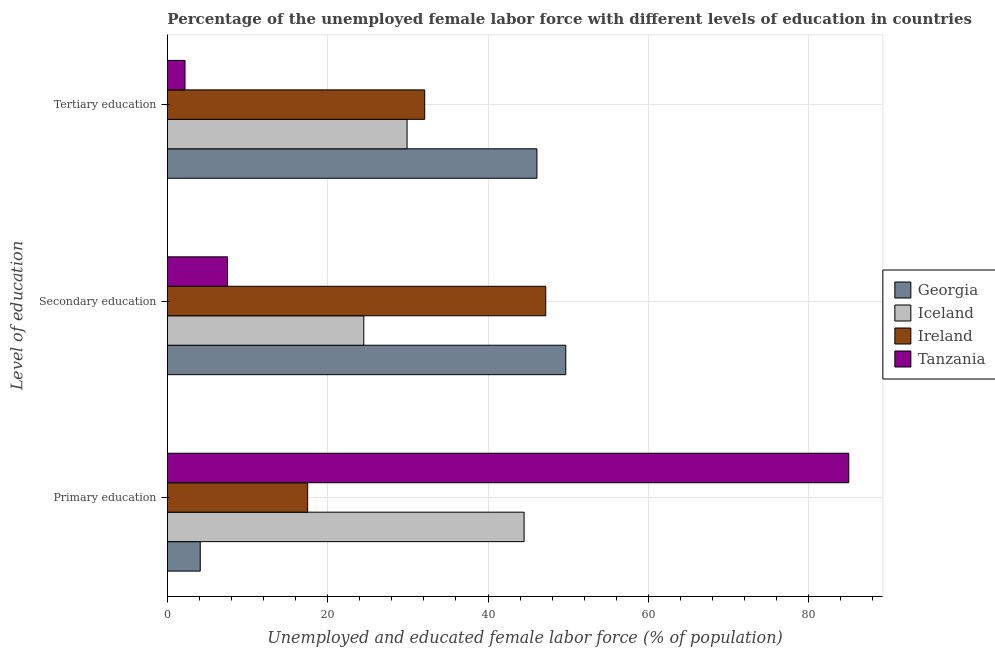Are the number of bars on each tick of the Y-axis equal?
Your response must be concise. Yes. How many bars are there on the 3rd tick from the top?
Offer a terse response. 4. How many bars are there on the 3rd tick from the bottom?
Provide a succinct answer. 4. What is the label of the 3rd group of bars from the top?
Your answer should be compact. Primary education. What is the percentage of female labor force who received secondary education in Georgia?
Ensure brevity in your answer.  49.7. Across all countries, what is the maximum percentage of female labor force who received primary education?
Keep it short and to the point. 85. Across all countries, what is the minimum percentage of female labor force who received primary education?
Keep it short and to the point. 4.1. In which country was the percentage of female labor force who received tertiary education maximum?
Your response must be concise. Georgia. In which country was the percentage of female labor force who received primary education minimum?
Ensure brevity in your answer.  Georgia. What is the total percentage of female labor force who received tertiary education in the graph?
Make the answer very short. 110.3. What is the difference between the percentage of female labor force who received primary education in Ireland and that in Tanzania?
Your response must be concise. -67.5. What is the difference between the percentage of female labor force who received tertiary education in Georgia and the percentage of female labor force who received secondary education in Iceland?
Your response must be concise. 21.6. What is the average percentage of female labor force who received tertiary education per country?
Offer a terse response. 27.57. What is the difference between the percentage of female labor force who received tertiary education and percentage of female labor force who received primary education in Georgia?
Ensure brevity in your answer.  42. In how many countries, is the percentage of female labor force who received tertiary education greater than 76 %?
Offer a terse response. 0. What is the ratio of the percentage of female labor force who received primary education in Ireland to that in Tanzania?
Make the answer very short. 0.21. Is the percentage of female labor force who received tertiary education in Iceland less than that in Ireland?
Your response must be concise. Yes. Is the difference between the percentage of female labor force who received secondary education in Iceland and Tanzania greater than the difference between the percentage of female labor force who received tertiary education in Iceland and Tanzania?
Keep it short and to the point. No. What is the difference between the highest and the second highest percentage of female labor force who received primary education?
Your response must be concise. 40.5. What is the difference between the highest and the lowest percentage of female labor force who received tertiary education?
Your answer should be very brief. 43.9. In how many countries, is the percentage of female labor force who received secondary education greater than the average percentage of female labor force who received secondary education taken over all countries?
Your answer should be compact. 2. Is it the case that in every country, the sum of the percentage of female labor force who received primary education and percentage of female labor force who received secondary education is greater than the percentage of female labor force who received tertiary education?
Offer a very short reply. Yes. How many bars are there?
Make the answer very short. 12. Are all the bars in the graph horizontal?
Your answer should be very brief. Yes. Are the values on the major ticks of X-axis written in scientific E-notation?
Provide a succinct answer. No. Does the graph contain grids?
Make the answer very short. Yes. How many legend labels are there?
Offer a very short reply. 4. How are the legend labels stacked?
Your answer should be very brief. Vertical. What is the title of the graph?
Provide a succinct answer. Percentage of the unemployed female labor force with different levels of education in countries. Does "Micronesia" appear as one of the legend labels in the graph?
Your response must be concise. No. What is the label or title of the X-axis?
Keep it short and to the point. Unemployed and educated female labor force (% of population). What is the label or title of the Y-axis?
Ensure brevity in your answer.  Level of education. What is the Unemployed and educated female labor force (% of population) in Georgia in Primary education?
Your answer should be very brief. 4.1. What is the Unemployed and educated female labor force (% of population) of Iceland in Primary education?
Offer a terse response. 44.5. What is the Unemployed and educated female labor force (% of population) of Ireland in Primary education?
Your answer should be very brief. 17.5. What is the Unemployed and educated female labor force (% of population) of Tanzania in Primary education?
Your response must be concise. 85. What is the Unemployed and educated female labor force (% of population) of Georgia in Secondary education?
Make the answer very short. 49.7. What is the Unemployed and educated female labor force (% of population) in Iceland in Secondary education?
Give a very brief answer. 24.5. What is the Unemployed and educated female labor force (% of population) of Ireland in Secondary education?
Your answer should be very brief. 47.2. What is the Unemployed and educated female labor force (% of population) in Georgia in Tertiary education?
Your answer should be compact. 46.1. What is the Unemployed and educated female labor force (% of population) of Iceland in Tertiary education?
Your answer should be compact. 29.9. What is the Unemployed and educated female labor force (% of population) of Ireland in Tertiary education?
Provide a short and direct response. 32.1. What is the Unemployed and educated female labor force (% of population) in Tanzania in Tertiary education?
Provide a succinct answer. 2.2. Across all Level of education, what is the maximum Unemployed and educated female labor force (% of population) in Georgia?
Make the answer very short. 49.7. Across all Level of education, what is the maximum Unemployed and educated female labor force (% of population) of Iceland?
Provide a succinct answer. 44.5. Across all Level of education, what is the maximum Unemployed and educated female labor force (% of population) in Ireland?
Provide a short and direct response. 47.2. Across all Level of education, what is the minimum Unemployed and educated female labor force (% of population) of Georgia?
Your response must be concise. 4.1. Across all Level of education, what is the minimum Unemployed and educated female labor force (% of population) in Iceland?
Make the answer very short. 24.5. Across all Level of education, what is the minimum Unemployed and educated female labor force (% of population) in Tanzania?
Provide a succinct answer. 2.2. What is the total Unemployed and educated female labor force (% of population) of Georgia in the graph?
Provide a short and direct response. 99.9. What is the total Unemployed and educated female labor force (% of population) of Iceland in the graph?
Make the answer very short. 98.9. What is the total Unemployed and educated female labor force (% of population) in Ireland in the graph?
Your answer should be very brief. 96.8. What is the total Unemployed and educated female labor force (% of population) of Tanzania in the graph?
Your answer should be compact. 94.7. What is the difference between the Unemployed and educated female labor force (% of population) of Georgia in Primary education and that in Secondary education?
Ensure brevity in your answer.  -45.6. What is the difference between the Unemployed and educated female labor force (% of population) of Ireland in Primary education and that in Secondary education?
Provide a short and direct response. -29.7. What is the difference between the Unemployed and educated female labor force (% of population) of Tanzania in Primary education and that in Secondary education?
Give a very brief answer. 77.5. What is the difference between the Unemployed and educated female labor force (% of population) of Georgia in Primary education and that in Tertiary education?
Make the answer very short. -42. What is the difference between the Unemployed and educated female labor force (% of population) in Iceland in Primary education and that in Tertiary education?
Offer a terse response. 14.6. What is the difference between the Unemployed and educated female labor force (% of population) of Ireland in Primary education and that in Tertiary education?
Make the answer very short. -14.6. What is the difference between the Unemployed and educated female labor force (% of population) in Tanzania in Primary education and that in Tertiary education?
Provide a succinct answer. 82.8. What is the difference between the Unemployed and educated female labor force (% of population) of Georgia in Secondary education and that in Tertiary education?
Ensure brevity in your answer.  3.6. What is the difference between the Unemployed and educated female labor force (% of population) of Georgia in Primary education and the Unemployed and educated female labor force (% of population) of Iceland in Secondary education?
Give a very brief answer. -20.4. What is the difference between the Unemployed and educated female labor force (% of population) in Georgia in Primary education and the Unemployed and educated female labor force (% of population) in Ireland in Secondary education?
Provide a short and direct response. -43.1. What is the difference between the Unemployed and educated female labor force (% of population) in Georgia in Primary education and the Unemployed and educated female labor force (% of population) in Tanzania in Secondary education?
Give a very brief answer. -3.4. What is the difference between the Unemployed and educated female labor force (% of population) in Iceland in Primary education and the Unemployed and educated female labor force (% of population) in Tanzania in Secondary education?
Your answer should be very brief. 37. What is the difference between the Unemployed and educated female labor force (% of population) in Ireland in Primary education and the Unemployed and educated female labor force (% of population) in Tanzania in Secondary education?
Provide a short and direct response. 10. What is the difference between the Unemployed and educated female labor force (% of population) of Georgia in Primary education and the Unemployed and educated female labor force (% of population) of Iceland in Tertiary education?
Make the answer very short. -25.8. What is the difference between the Unemployed and educated female labor force (% of population) of Georgia in Primary education and the Unemployed and educated female labor force (% of population) of Ireland in Tertiary education?
Your response must be concise. -28. What is the difference between the Unemployed and educated female labor force (% of population) in Georgia in Primary education and the Unemployed and educated female labor force (% of population) in Tanzania in Tertiary education?
Your answer should be compact. 1.9. What is the difference between the Unemployed and educated female labor force (% of population) of Iceland in Primary education and the Unemployed and educated female labor force (% of population) of Ireland in Tertiary education?
Your answer should be very brief. 12.4. What is the difference between the Unemployed and educated female labor force (% of population) in Iceland in Primary education and the Unemployed and educated female labor force (% of population) in Tanzania in Tertiary education?
Provide a short and direct response. 42.3. What is the difference between the Unemployed and educated female labor force (% of population) of Georgia in Secondary education and the Unemployed and educated female labor force (% of population) of Iceland in Tertiary education?
Provide a succinct answer. 19.8. What is the difference between the Unemployed and educated female labor force (% of population) in Georgia in Secondary education and the Unemployed and educated female labor force (% of population) in Ireland in Tertiary education?
Ensure brevity in your answer.  17.6. What is the difference between the Unemployed and educated female labor force (% of population) of Georgia in Secondary education and the Unemployed and educated female labor force (% of population) of Tanzania in Tertiary education?
Make the answer very short. 47.5. What is the difference between the Unemployed and educated female labor force (% of population) in Iceland in Secondary education and the Unemployed and educated female labor force (% of population) in Ireland in Tertiary education?
Provide a succinct answer. -7.6. What is the difference between the Unemployed and educated female labor force (% of population) in Iceland in Secondary education and the Unemployed and educated female labor force (% of population) in Tanzania in Tertiary education?
Your answer should be compact. 22.3. What is the average Unemployed and educated female labor force (% of population) of Georgia per Level of education?
Provide a short and direct response. 33.3. What is the average Unemployed and educated female labor force (% of population) in Iceland per Level of education?
Your response must be concise. 32.97. What is the average Unemployed and educated female labor force (% of population) of Ireland per Level of education?
Your answer should be compact. 32.27. What is the average Unemployed and educated female labor force (% of population) of Tanzania per Level of education?
Provide a short and direct response. 31.57. What is the difference between the Unemployed and educated female labor force (% of population) in Georgia and Unemployed and educated female labor force (% of population) in Iceland in Primary education?
Offer a very short reply. -40.4. What is the difference between the Unemployed and educated female labor force (% of population) in Georgia and Unemployed and educated female labor force (% of population) in Ireland in Primary education?
Give a very brief answer. -13.4. What is the difference between the Unemployed and educated female labor force (% of population) in Georgia and Unemployed and educated female labor force (% of population) in Tanzania in Primary education?
Make the answer very short. -80.9. What is the difference between the Unemployed and educated female labor force (% of population) of Iceland and Unemployed and educated female labor force (% of population) of Tanzania in Primary education?
Offer a terse response. -40.5. What is the difference between the Unemployed and educated female labor force (% of population) in Ireland and Unemployed and educated female labor force (% of population) in Tanzania in Primary education?
Offer a very short reply. -67.5. What is the difference between the Unemployed and educated female labor force (% of population) of Georgia and Unemployed and educated female labor force (% of population) of Iceland in Secondary education?
Your answer should be compact. 25.2. What is the difference between the Unemployed and educated female labor force (% of population) of Georgia and Unemployed and educated female labor force (% of population) of Tanzania in Secondary education?
Ensure brevity in your answer.  42.2. What is the difference between the Unemployed and educated female labor force (% of population) in Iceland and Unemployed and educated female labor force (% of population) in Ireland in Secondary education?
Provide a short and direct response. -22.7. What is the difference between the Unemployed and educated female labor force (% of population) in Iceland and Unemployed and educated female labor force (% of population) in Tanzania in Secondary education?
Keep it short and to the point. 17. What is the difference between the Unemployed and educated female labor force (% of population) of Ireland and Unemployed and educated female labor force (% of population) of Tanzania in Secondary education?
Make the answer very short. 39.7. What is the difference between the Unemployed and educated female labor force (% of population) of Georgia and Unemployed and educated female labor force (% of population) of Iceland in Tertiary education?
Give a very brief answer. 16.2. What is the difference between the Unemployed and educated female labor force (% of population) in Georgia and Unemployed and educated female labor force (% of population) in Tanzania in Tertiary education?
Provide a succinct answer. 43.9. What is the difference between the Unemployed and educated female labor force (% of population) of Iceland and Unemployed and educated female labor force (% of population) of Ireland in Tertiary education?
Keep it short and to the point. -2.2. What is the difference between the Unemployed and educated female labor force (% of population) of Iceland and Unemployed and educated female labor force (% of population) of Tanzania in Tertiary education?
Provide a succinct answer. 27.7. What is the difference between the Unemployed and educated female labor force (% of population) in Ireland and Unemployed and educated female labor force (% of population) in Tanzania in Tertiary education?
Provide a short and direct response. 29.9. What is the ratio of the Unemployed and educated female labor force (% of population) in Georgia in Primary education to that in Secondary education?
Provide a succinct answer. 0.08. What is the ratio of the Unemployed and educated female labor force (% of population) of Iceland in Primary education to that in Secondary education?
Keep it short and to the point. 1.82. What is the ratio of the Unemployed and educated female labor force (% of population) of Ireland in Primary education to that in Secondary education?
Your answer should be very brief. 0.37. What is the ratio of the Unemployed and educated female labor force (% of population) in Tanzania in Primary education to that in Secondary education?
Provide a succinct answer. 11.33. What is the ratio of the Unemployed and educated female labor force (% of population) in Georgia in Primary education to that in Tertiary education?
Provide a succinct answer. 0.09. What is the ratio of the Unemployed and educated female labor force (% of population) of Iceland in Primary education to that in Tertiary education?
Your response must be concise. 1.49. What is the ratio of the Unemployed and educated female labor force (% of population) of Ireland in Primary education to that in Tertiary education?
Provide a short and direct response. 0.55. What is the ratio of the Unemployed and educated female labor force (% of population) in Tanzania in Primary education to that in Tertiary education?
Give a very brief answer. 38.64. What is the ratio of the Unemployed and educated female labor force (% of population) in Georgia in Secondary education to that in Tertiary education?
Offer a terse response. 1.08. What is the ratio of the Unemployed and educated female labor force (% of population) in Iceland in Secondary education to that in Tertiary education?
Offer a terse response. 0.82. What is the ratio of the Unemployed and educated female labor force (% of population) of Ireland in Secondary education to that in Tertiary education?
Offer a terse response. 1.47. What is the ratio of the Unemployed and educated female labor force (% of population) in Tanzania in Secondary education to that in Tertiary education?
Your answer should be compact. 3.41. What is the difference between the highest and the second highest Unemployed and educated female labor force (% of population) of Georgia?
Your response must be concise. 3.6. What is the difference between the highest and the second highest Unemployed and educated female labor force (% of population) of Tanzania?
Your response must be concise. 77.5. What is the difference between the highest and the lowest Unemployed and educated female labor force (% of population) in Georgia?
Offer a terse response. 45.6. What is the difference between the highest and the lowest Unemployed and educated female labor force (% of population) in Ireland?
Your answer should be very brief. 29.7. What is the difference between the highest and the lowest Unemployed and educated female labor force (% of population) in Tanzania?
Keep it short and to the point. 82.8. 